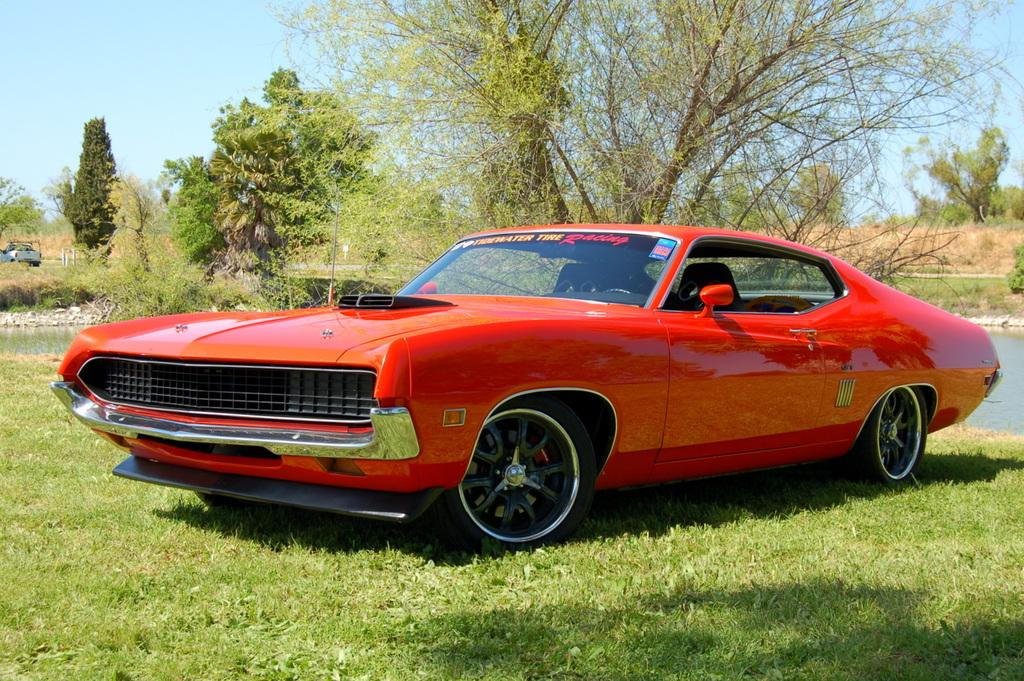What type of objects are in the image? There are vehicles in the image. Where are the vehicles located? The vehicles are on the grass. What can be seen in the background of the image? There is a lake and trees visible in the background of the image. Can you see any rabbits or bears in the image? There are no rabbits or bears present in the image. What part of the human body can be seen in the image? There is no human body present in the image; it features vehicles on the grass with a lake and trees in the background. 